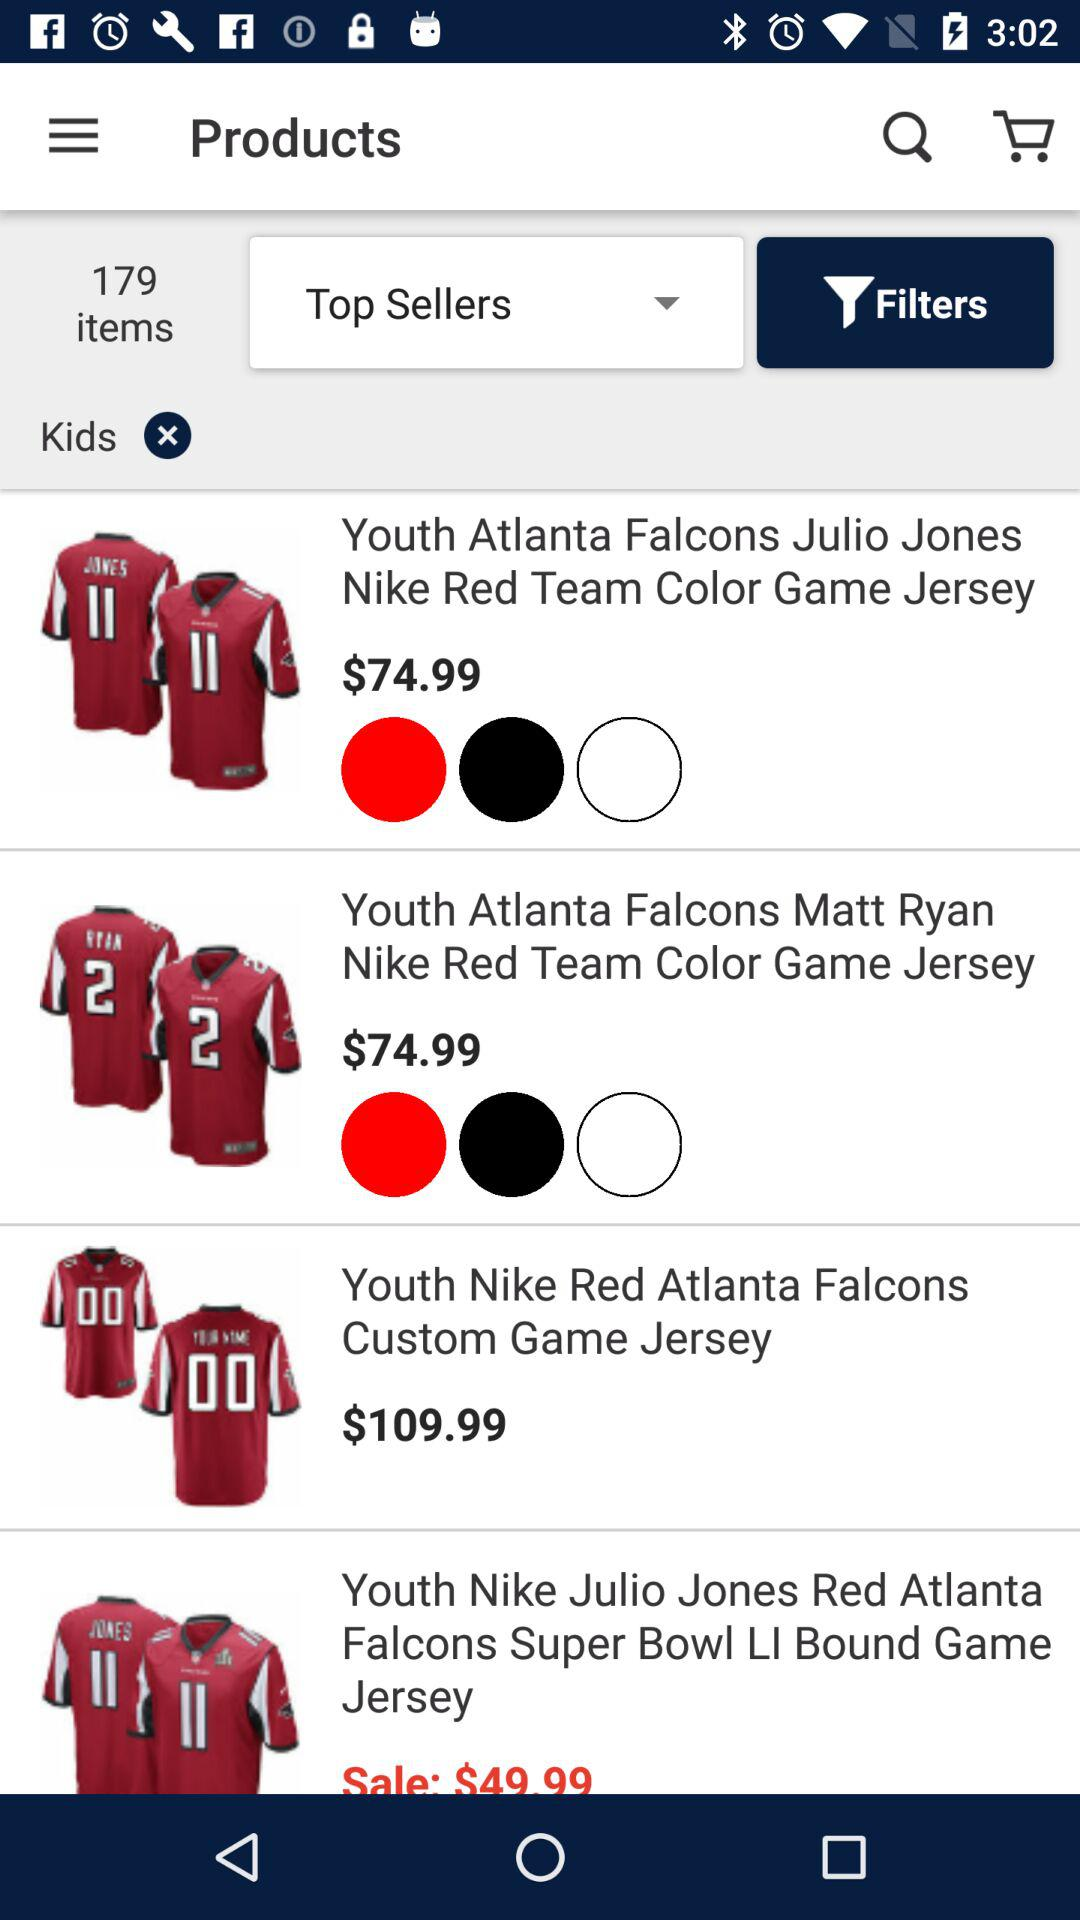How much is the most expensive item?
Answer the question using a single word or phrase. $109.99 